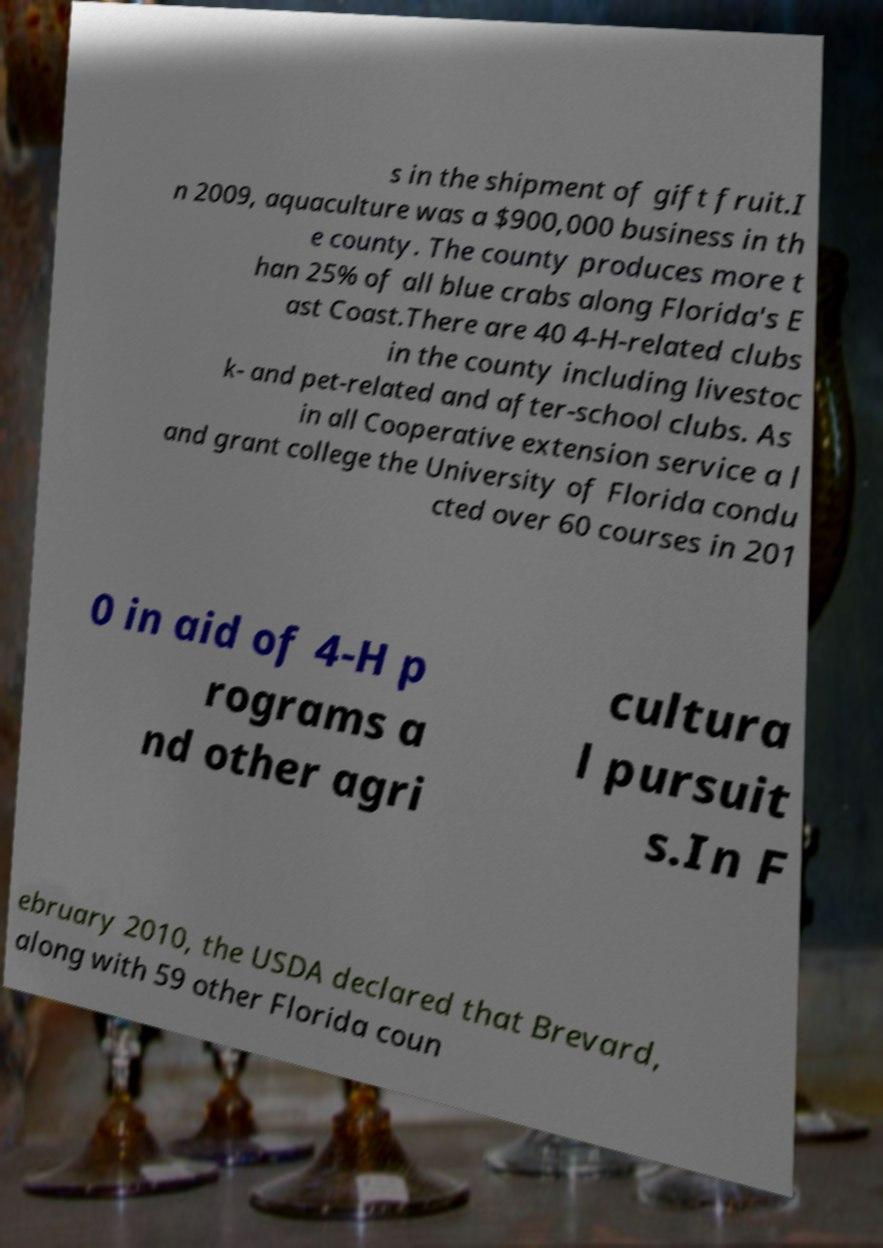Can you read and provide the text displayed in the image?This photo seems to have some interesting text. Can you extract and type it out for me? s in the shipment of gift fruit.I n 2009, aquaculture was a $900,000 business in th e county. The county produces more t han 25% of all blue crabs along Florida's E ast Coast.There are 40 4-H-related clubs in the county including livestoc k- and pet-related and after-school clubs. As in all Cooperative extension service a l and grant college the University of Florida condu cted over 60 courses in 201 0 in aid of 4-H p rograms a nd other agri cultura l pursuit s.In F ebruary 2010, the USDA declared that Brevard, along with 59 other Florida coun 